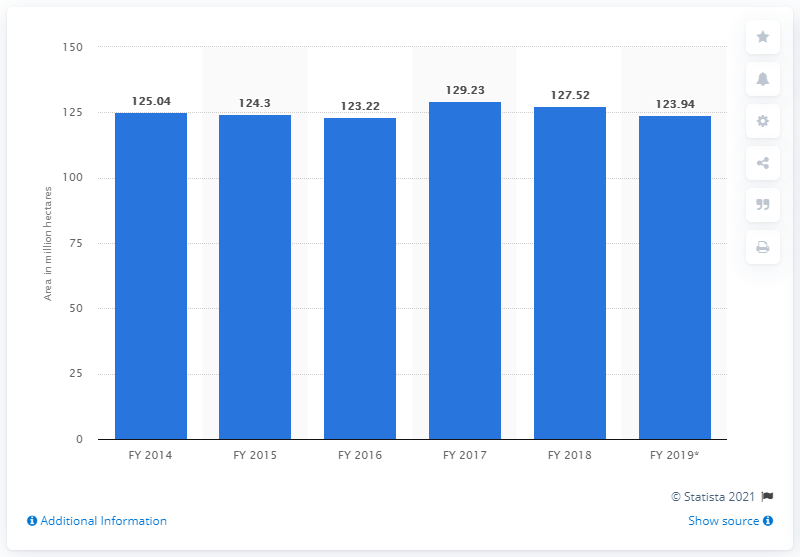Highlight a few significant elements in this photo. At the end of the fiscal year 2019, India had 123.94 square kilometers of land available for the cultivation of food grains. 